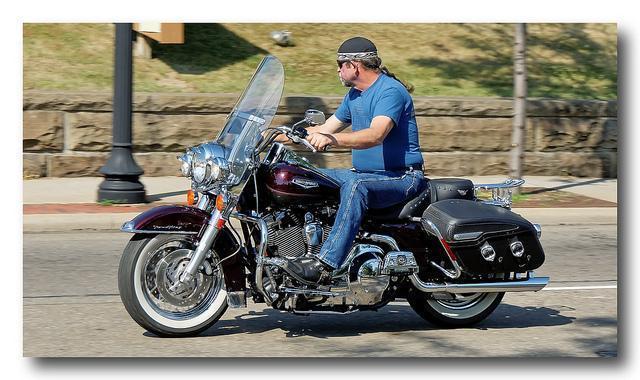How many ski lift chairs are visible?
Give a very brief answer. 0. 